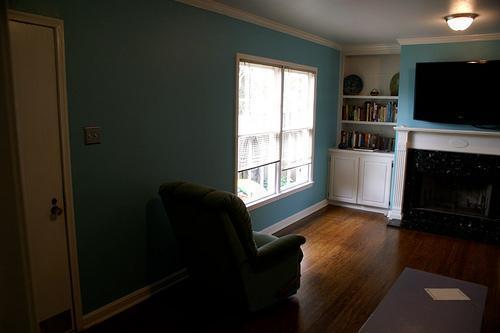How many train cars are visible?
Give a very brief answer. 0. 